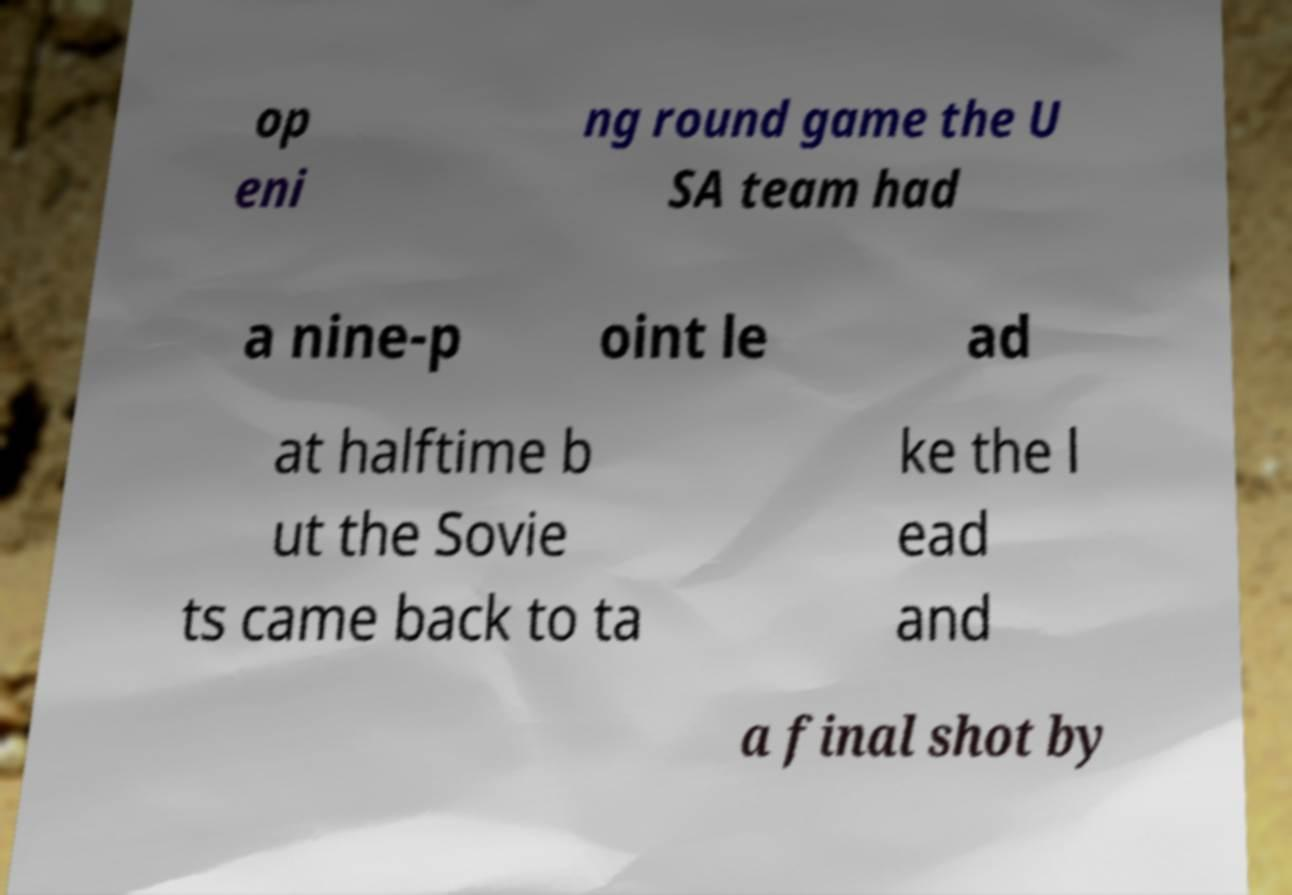Please identify and transcribe the text found in this image. op eni ng round game the U SA team had a nine-p oint le ad at halftime b ut the Sovie ts came back to ta ke the l ead and a final shot by 